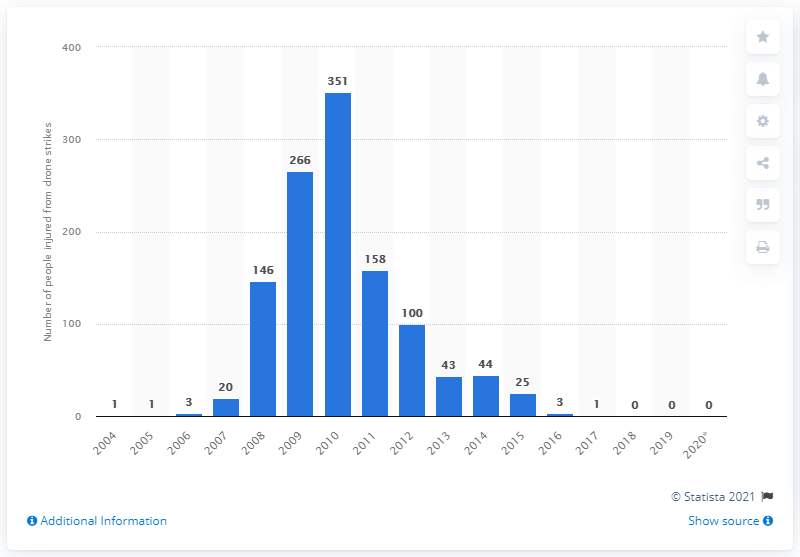List a handful of essential elements in this visual. In 2019, there were no drone strikes carried out by the United States in Pakistan. 